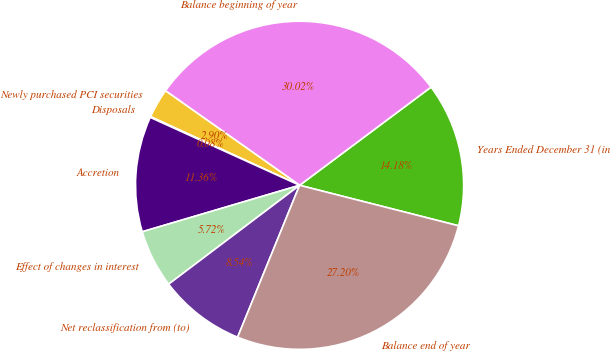Convert chart to OTSL. <chart><loc_0><loc_0><loc_500><loc_500><pie_chart><fcel>Years Ended December 31 (in<fcel>Balance beginning of year<fcel>Newly purchased PCI securities<fcel>Disposals<fcel>Accretion<fcel>Effect of changes in interest<fcel>Net reclassification from (to)<fcel>Balance end of year<nl><fcel>14.18%<fcel>30.01%<fcel>2.9%<fcel>0.08%<fcel>11.36%<fcel>5.72%<fcel>8.54%<fcel>27.19%<nl></chart> 